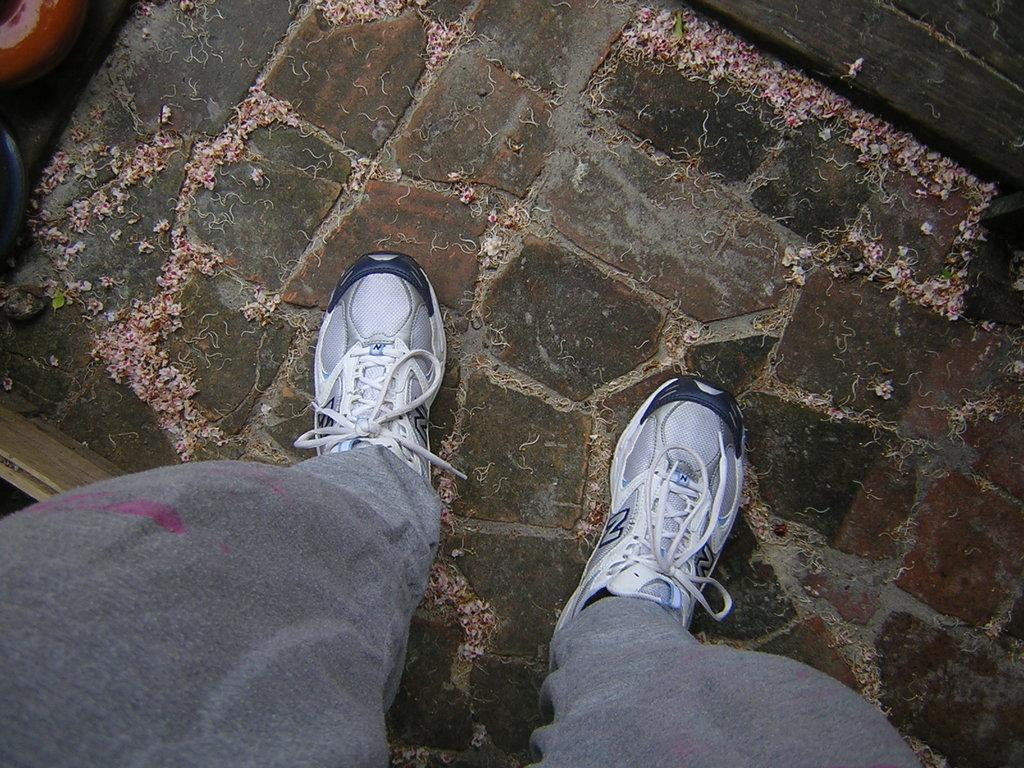What part of a person can be seen in the image? There are legs of a person visible in the image. What type of footwear is the person wearing? The person is wearing shoes. What type of clothing is visible on the person's legs? The person's pant is visible. What object can be seen on the top right side of the image? There is a wooden block on the top right side of the image. What religion is the person practicing in the image? There is no indication of any religious practice in the image. Is there a balloon visible in the image? No, there is no balloon present in the image. 